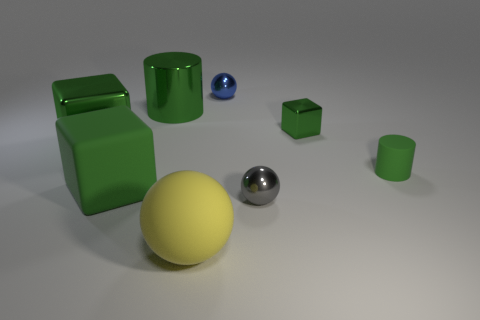What number of things are objects to the right of the rubber sphere or spheres?
Your response must be concise. 5. Is the color of the thing behind the big green cylinder the same as the rubber block?
Provide a short and direct response. No. What size is the metallic object that is the same shape as the small green matte object?
Keep it short and to the point. Large. What color is the metal sphere behind the big green thing that is in front of the large block to the left of the large matte cube?
Provide a succinct answer. Blue. Does the tiny gray sphere have the same material as the blue ball?
Make the answer very short. Yes. There is a ball that is on the left side of the metal object that is behind the large metal cylinder; is there a small green cylinder that is to the right of it?
Provide a short and direct response. Yes. Does the large metal cube have the same color as the big ball?
Ensure brevity in your answer.  No. Is the number of large purple balls less than the number of balls?
Your response must be concise. Yes. Do the small sphere that is in front of the blue metallic object and the cylinder that is on the left side of the gray metal ball have the same material?
Provide a succinct answer. Yes. Is the number of rubber cylinders to the left of the small blue metal sphere less than the number of purple metal things?
Your response must be concise. No. 